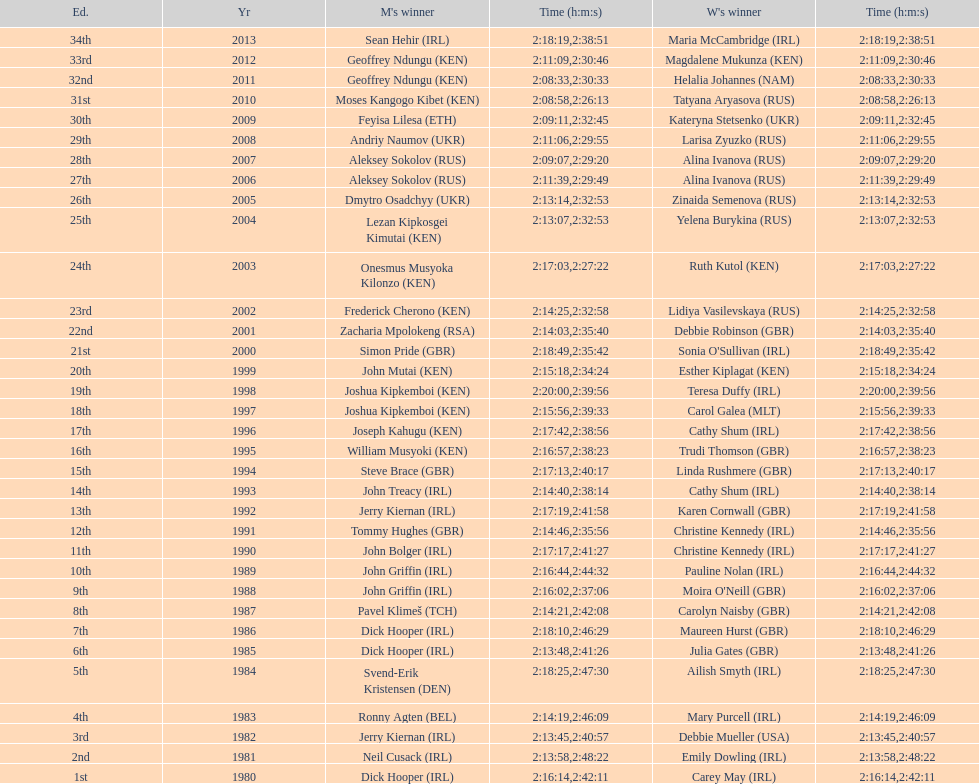How many women's winners are from kenya? 3. 